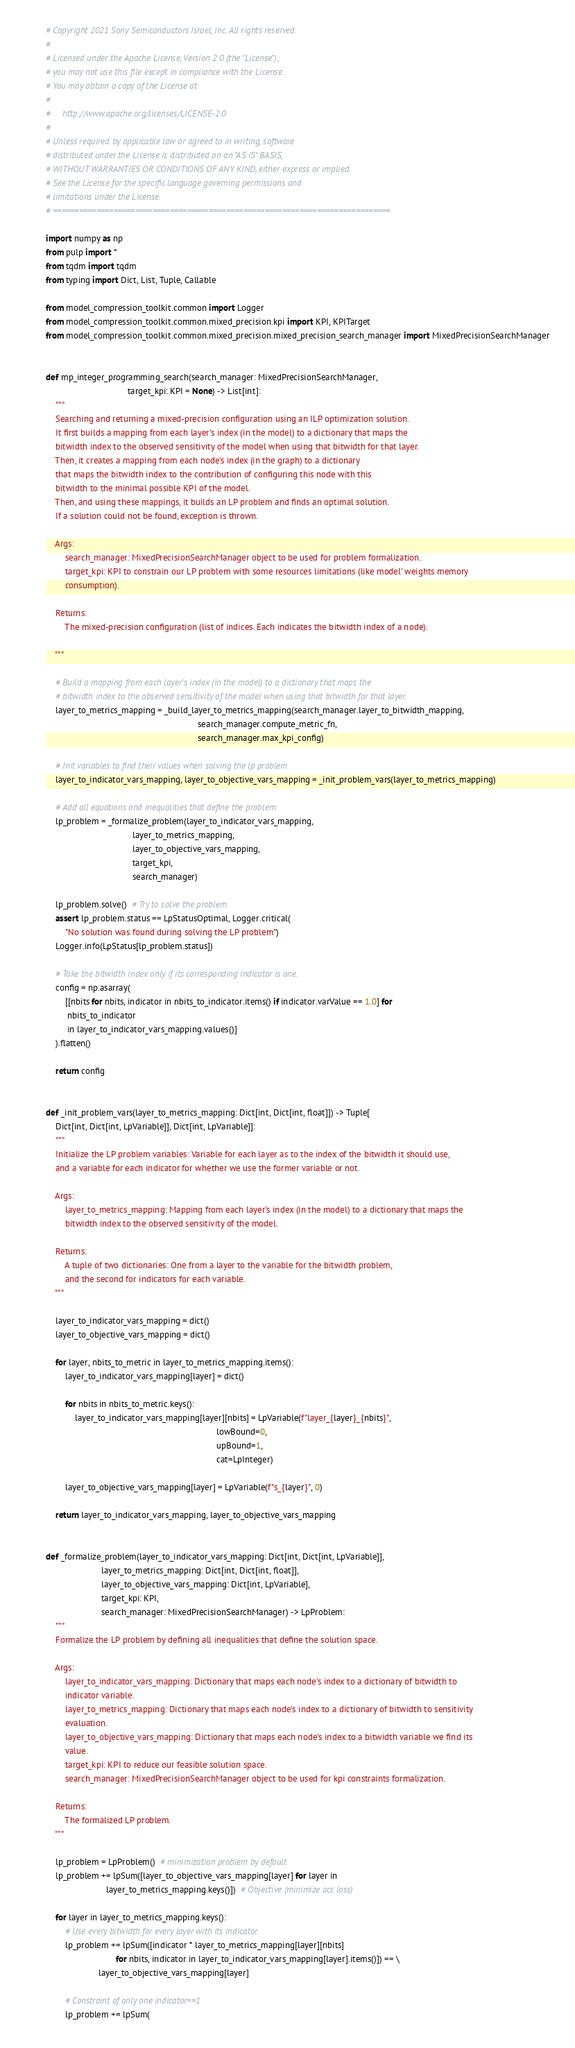Convert code to text. <code><loc_0><loc_0><loc_500><loc_500><_Python_># Copyright 2021 Sony Semiconductors Israel, Inc. All rights reserved.
#
# Licensed under the Apache License, Version 2.0 (the "License");
# you may not use this file except in compliance with the License.
# You may obtain a copy of the License at
#
#     http://www.apache.org/licenses/LICENSE-2.0
#
# Unless required by applicable law or agreed to in writing, software
# distributed under the License is distributed on an "AS IS" BASIS,
# WITHOUT WARRANTIES OR CONDITIONS OF ANY KIND, either express or implied.
# See the License for the specific language governing permissions and
# limitations under the License.
# ==============================================================================

import numpy as np
from pulp import *
from tqdm import tqdm
from typing import Dict, List, Tuple, Callable

from model_compression_toolkit.common import Logger
from model_compression_toolkit.common.mixed_precision.kpi import KPI, KPITarget
from model_compression_toolkit.common.mixed_precision.mixed_precision_search_manager import MixedPrecisionSearchManager


def mp_integer_programming_search(search_manager: MixedPrecisionSearchManager,
                                  target_kpi: KPI = None) -> List[int]:
    """
    Searching and returning a mixed-precision configuration using an ILP optimization solution.
    It first builds a mapping from each layer's index (in the model) to a dictionary that maps the
    bitwidth index to the observed sensitivity of the model when using that bitwidth for that layer.
    Then, it creates a mapping from each node's index (in the graph) to a dictionary
    that maps the bitwidth index to the contribution of configuring this node with this
    bitwidth to the minimal possible KPI of the model.
    Then, and using these mappings, it builds an LP problem and finds an optimal solution.
    If a solution could not be found, exception is thrown.

    Args:
        search_manager: MixedPrecisionSearchManager object to be used for problem formalization.
        target_kpi: KPI to constrain our LP problem with some resources limitations (like model' weights memory
        consumption).

    Returns:
        The mixed-precision configuration (list of indices. Each indicates the bitwidth index of a node).

    """

    # Build a mapping from each layer's index (in the model) to a dictionary that maps the
    # bitwidth index to the observed sensitivity of the model when using that bitwidth for that layer.
    layer_to_metrics_mapping = _build_layer_to_metrics_mapping(search_manager.layer_to_bitwidth_mapping,
                                                               search_manager.compute_metric_fn,
                                                               search_manager.max_kpi_config)

    # Init variables to find their values when solving the lp problem.
    layer_to_indicator_vars_mapping, layer_to_objective_vars_mapping = _init_problem_vars(layer_to_metrics_mapping)

    # Add all equations and inequalities that define the problem.
    lp_problem = _formalize_problem(layer_to_indicator_vars_mapping,
                                    layer_to_metrics_mapping,
                                    layer_to_objective_vars_mapping,
                                    target_kpi,
                                    search_manager)

    lp_problem.solve()  # Try to solve the problem.
    assert lp_problem.status == LpStatusOptimal, Logger.critical(
        "No solution was found during solving the LP problem")
    Logger.info(LpStatus[lp_problem.status])

    # Take the bitwidth index only if its corresponding indicator is one.
    config = np.asarray(
        [[nbits for nbits, indicator in nbits_to_indicator.items() if indicator.varValue == 1.0] for
         nbits_to_indicator
         in layer_to_indicator_vars_mapping.values()]
    ).flatten()

    return config


def _init_problem_vars(layer_to_metrics_mapping: Dict[int, Dict[int, float]]) -> Tuple[
    Dict[int, Dict[int, LpVariable]], Dict[int, LpVariable]]:
    """
    Initialize the LP problem variables: Variable for each layer as to the index of the bitwidth it should use,
    and a variable for each indicator for whether we use the former variable or not.

    Args:
        layer_to_metrics_mapping: Mapping from each layer's index (in the model) to a dictionary that maps the
        bitwidth index to the observed sensitivity of the model.

    Returns:
        A tuple of two dictionaries: One from a layer to the variable for the bitwidth problem,
        and the second for indicators for each variable.
    """

    layer_to_indicator_vars_mapping = dict()
    layer_to_objective_vars_mapping = dict()

    for layer, nbits_to_metric in layer_to_metrics_mapping.items():
        layer_to_indicator_vars_mapping[layer] = dict()

        for nbits in nbits_to_metric.keys():
            layer_to_indicator_vars_mapping[layer][nbits] = LpVariable(f"layer_{layer}_{nbits}",
                                                                       lowBound=0,
                                                                       upBound=1,
                                                                       cat=LpInteger)

        layer_to_objective_vars_mapping[layer] = LpVariable(f"s_{layer}", 0)

    return layer_to_indicator_vars_mapping, layer_to_objective_vars_mapping


def _formalize_problem(layer_to_indicator_vars_mapping: Dict[int, Dict[int, LpVariable]],
                       layer_to_metrics_mapping: Dict[int, Dict[int, float]],
                       layer_to_objective_vars_mapping: Dict[int, LpVariable],
                       target_kpi: KPI,
                       search_manager: MixedPrecisionSearchManager) -> LpProblem:
    """
    Formalize the LP problem by defining all inequalities that define the solution space.

    Args:
        layer_to_indicator_vars_mapping: Dictionary that maps each node's index to a dictionary of bitwidth to
        indicator variable.
        layer_to_metrics_mapping: Dictionary that maps each node's index to a dictionary of bitwidth to sensitivity
        evaluation.
        layer_to_objective_vars_mapping: Dictionary that maps each node's index to a bitwidth variable we find its
        value.
        target_kpi: KPI to reduce our feasible solution space.
        search_manager: MixedPrecisionSearchManager object to be used for kpi constraints formalization.

    Returns:
        The formalized LP problem.
    """

    lp_problem = LpProblem()  # minimization problem by default
    lp_problem += lpSum([layer_to_objective_vars_mapping[layer] for layer in
                         layer_to_metrics_mapping.keys()])  # Objective (minimize acc loss)

    for layer in layer_to_metrics_mapping.keys():
        # Use every bitwidth for every layer with its indicator.
        lp_problem += lpSum([indicator * layer_to_metrics_mapping[layer][nbits]
                             for nbits, indicator in layer_to_indicator_vars_mapping[layer].items()]) == \
                      layer_to_objective_vars_mapping[layer]

        # Constraint of only one indicator==1
        lp_problem += lpSum(</code> 